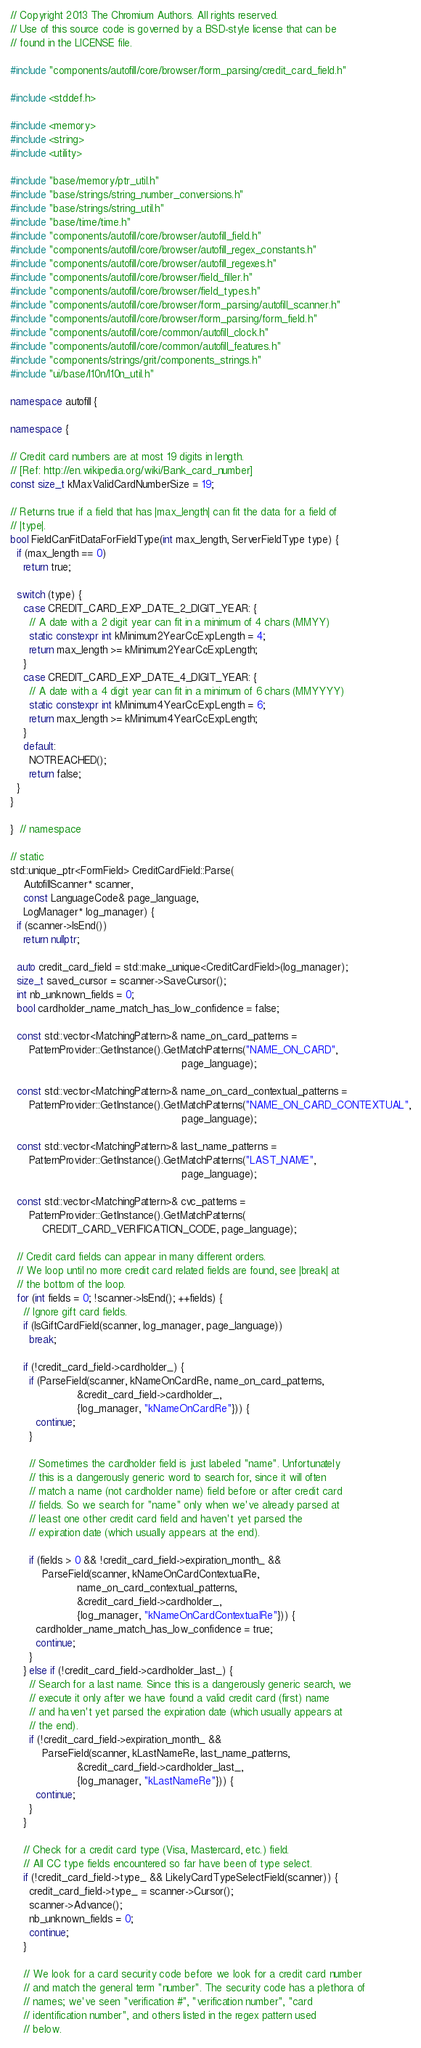<code> <loc_0><loc_0><loc_500><loc_500><_C++_>// Copyright 2013 The Chromium Authors. All rights reserved.
// Use of this source code is governed by a BSD-style license that can be
// found in the LICENSE file.

#include "components/autofill/core/browser/form_parsing/credit_card_field.h"

#include <stddef.h>

#include <memory>
#include <string>
#include <utility>

#include "base/memory/ptr_util.h"
#include "base/strings/string_number_conversions.h"
#include "base/strings/string_util.h"
#include "base/time/time.h"
#include "components/autofill/core/browser/autofill_field.h"
#include "components/autofill/core/browser/autofill_regex_constants.h"
#include "components/autofill/core/browser/autofill_regexes.h"
#include "components/autofill/core/browser/field_filler.h"
#include "components/autofill/core/browser/field_types.h"
#include "components/autofill/core/browser/form_parsing/autofill_scanner.h"
#include "components/autofill/core/browser/form_parsing/form_field.h"
#include "components/autofill/core/common/autofill_clock.h"
#include "components/autofill/core/common/autofill_features.h"
#include "components/strings/grit/components_strings.h"
#include "ui/base/l10n/l10n_util.h"

namespace autofill {

namespace {

// Credit card numbers are at most 19 digits in length.
// [Ref: http://en.wikipedia.org/wiki/Bank_card_number]
const size_t kMaxValidCardNumberSize = 19;

// Returns true if a field that has |max_length| can fit the data for a field of
// |type|.
bool FieldCanFitDataForFieldType(int max_length, ServerFieldType type) {
  if (max_length == 0)
    return true;

  switch (type) {
    case CREDIT_CARD_EXP_DATE_2_DIGIT_YEAR: {
      // A date with a 2 digit year can fit in a minimum of 4 chars (MMYY)
      static constexpr int kMinimum2YearCcExpLength = 4;
      return max_length >= kMinimum2YearCcExpLength;
    }
    case CREDIT_CARD_EXP_DATE_4_DIGIT_YEAR: {
      // A date with a 4 digit year can fit in a minimum of 6 chars (MMYYYY)
      static constexpr int kMinimum4YearCcExpLength = 6;
      return max_length >= kMinimum4YearCcExpLength;
    }
    default:
      NOTREACHED();
      return false;
  }
}

}  // namespace

// static
std::unique_ptr<FormField> CreditCardField::Parse(
    AutofillScanner* scanner,
    const LanguageCode& page_language,
    LogManager* log_manager) {
  if (scanner->IsEnd())
    return nullptr;

  auto credit_card_field = std::make_unique<CreditCardField>(log_manager);
  size_t saved_cursor = scanner->SaveCursor();
  int nb_unknown_fields = 0;
  bool cardholder_name_match_has_low_confidence = false;

  const std::vector<MatchingPattern>& name_on_card_patterns =
      PatternProvider::GetInstance().GetMatchPatterns("NAME_ON_CARD",
                                                      page_language);

  const std::vector<MatchingPattern>& name_on_card_contextual_patterns =
      PatternProvider::GetInstance().GetMatchPatterns("NAME_ON_CARD_CONTEXTUAL",
                                                      page_language);

  const std::vector<MatchingPattern>& last_name_patterns =
      PatternProvider::GetInstance().GetMatchPatterns("LAST_NAME",
                                                      page_language);

  const std::vector<MatchingPattern>& cvc_patterns =
      PatternProvider::GetInstance().GetMatchPatterns(
          CREDIT_CARD_VERIFICATION_CODE, page_language);

  // Credit card fields can appear in many different orders.
  // We loop until no more credit card related fields are found, see |break| at
  // the bottom of the loop.
  for (int fields = 0; !scanner->IsEnd(); ++fields) {
    // Ignore gift card fields.
    if (IsGiftCardField(scanner, log_manager, page_language))
      break;

    if (!credit_card_field->cardholder_) {
      if (ParseField(scanner, kNameOnCardRe, name_on_card_patterns,
                     &credit_card_field->cardholder_,
                     {log_manager, "kNameOnCardRe"})) {
        continue;
      }

      // Sometimes the cardholder field is just labeled "name". Unfortunately
      // this is a dangerously generic word to search for, since it will often
      // match a name (not cardholder name) field before or after credit card
      // fields. So we search for "name" only when we've already parsed at
      // least one other credit card field and haven't yet parsed the
      // expiration date (which usually appears at the end).

      if (fields > 0 && !credit_card_field->expiration_month_ &&
          ParseField(scanner, kNameOnCardContextualRe,
                     name_on_card_contextual_patterns,
                     &credit_card_field->cardholder_,
                     {log_manager, "kNameOnCardContextualRe"})) {
        cardholder_name_match_has_low_confidence = true;
        continue;
      }
    } else if (!credit_card_field->cardholder_last_) {
      // Search for a last name. Since this is a dangerously generic search, we
      // execute it only after we have found a valid credit card (first) name
      // and haven't yet parsed the expiration date (which usually appears at
      // the end).
      if (!credit_card_field->expiration_month_ &&
          ParseField(scanner, kLastNameRe, last_name_patterns,
                     &credit_card_field->cardholder_last_,
                     {log_manager, "kLastNameRe"})) {
        continue;
      }
    }

    // Check for a credit card type (Visa, Mastercard, etc.) field.
    // All CC type fields encountered so far have been of type select.
    if (!credit_card_field->type_ && LikelyCardTypeSelectField(scanner)) {
      credit_card_field->type_ = scanner->Cursor();
      scanner->Advance();
      nb_unknown_fields = 0;
      continue;
    }

    // We look for a card security code before we look for a credit card number
    // and match the general term "number". The security code has a plethora of
    // names; we've seen "verification #", "verification number", "card
    // identification number", and others listed in the regex pattern used
    // below.</code> 